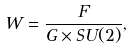Convert formula to latex. <formula><loc_0><loc_0><loc_500><loc_500>W = \frac { F } { G \times S U ( 2 ) } ,</formula> 